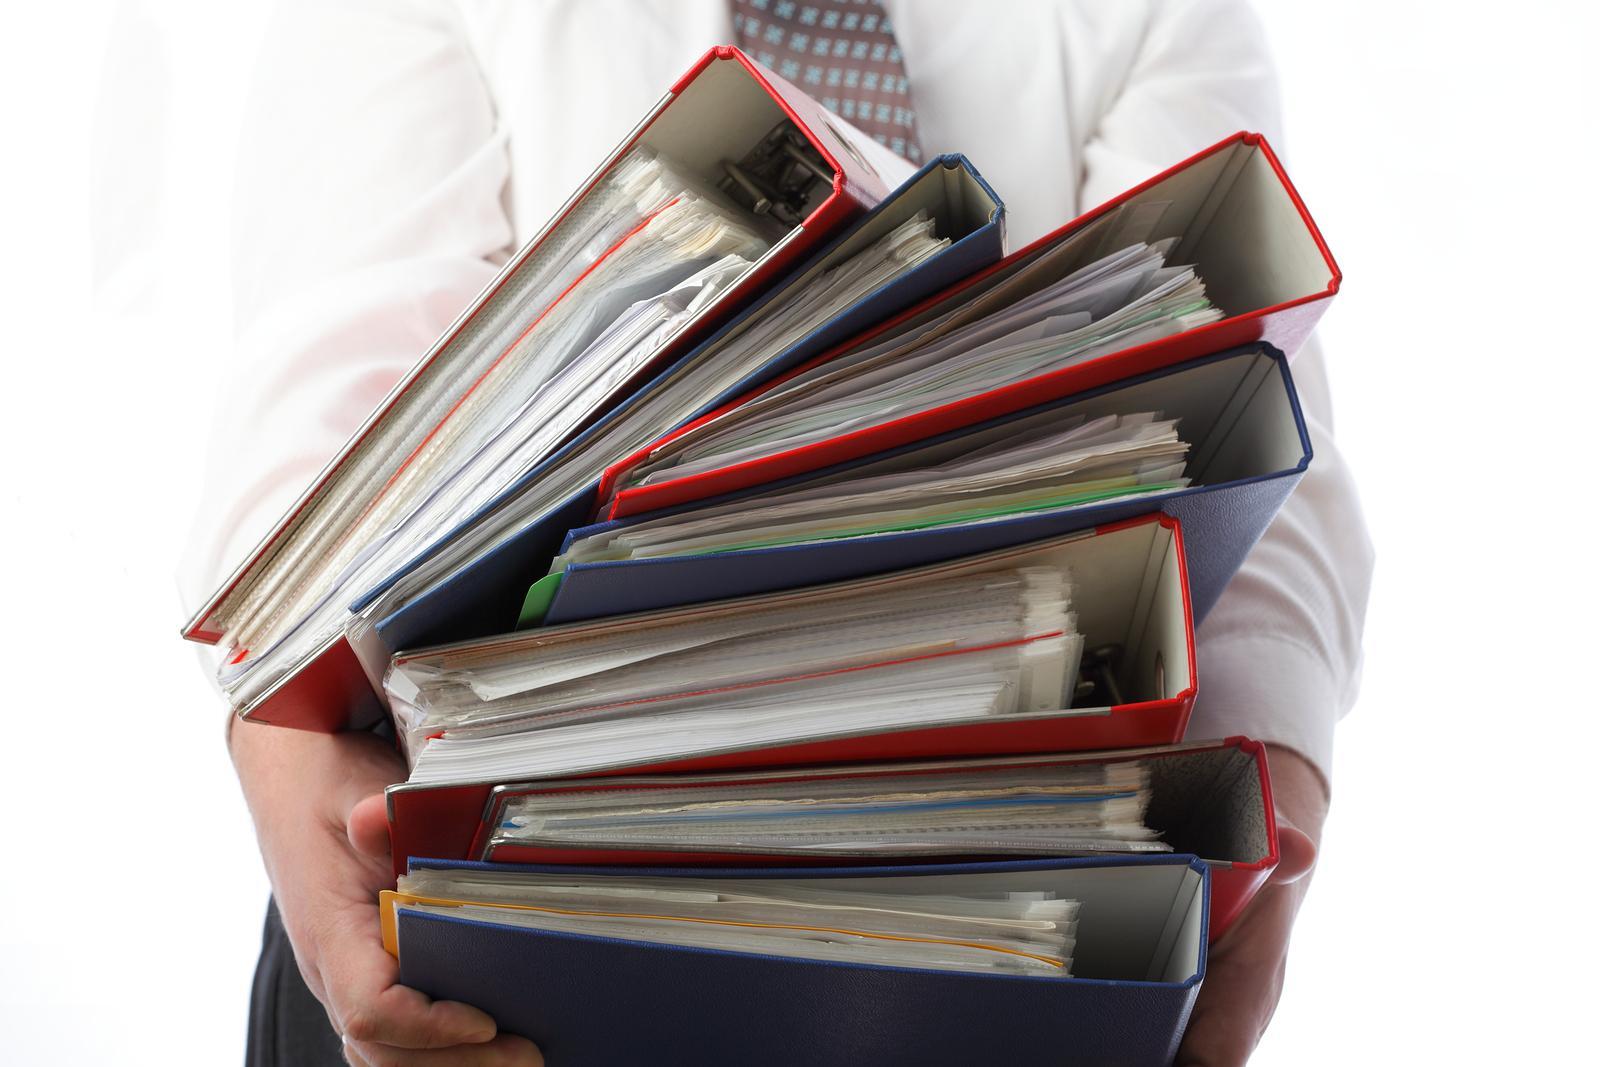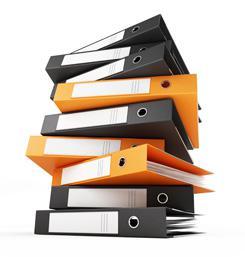The first image is the image on the left, the second image is the image on the right. Given the left and right images, does the statement "In one image, at least one orange notebook is closed and lying flat with the opening to the back, while the second image shows at least one notebook that is orange and black with no visible contents." hold true? Answer yes or no. No. The first image is the image on the left, the second image is the image on the right. Examine the images to the left and right. Is the description "An image shows a stack of at least eight binders that appears to sit on a flat surface." accurate? Answer yes or no. Yes. 